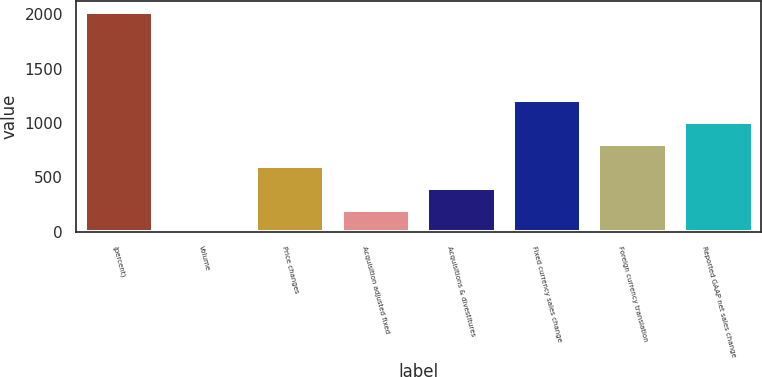Convert chart. <chart><loc_0><loc_0><loc_500><loc_500><bar_chart><fcel>(percent)<fcel>Volume<fcel>Price changes<fcel>Acquisition adjusted fixed<fcel>Acquisitions & divestitures<fcel>Fixed currency sales change<fcel>Foreign currency translation<fcel>Reported GAAP net sales change<nl><fcel>2016<fcel>1<fcel>605.5<fcel>202.5<fcel>404<fcel>1210<fcel>807<fcel>1008.5<nl></chart> 